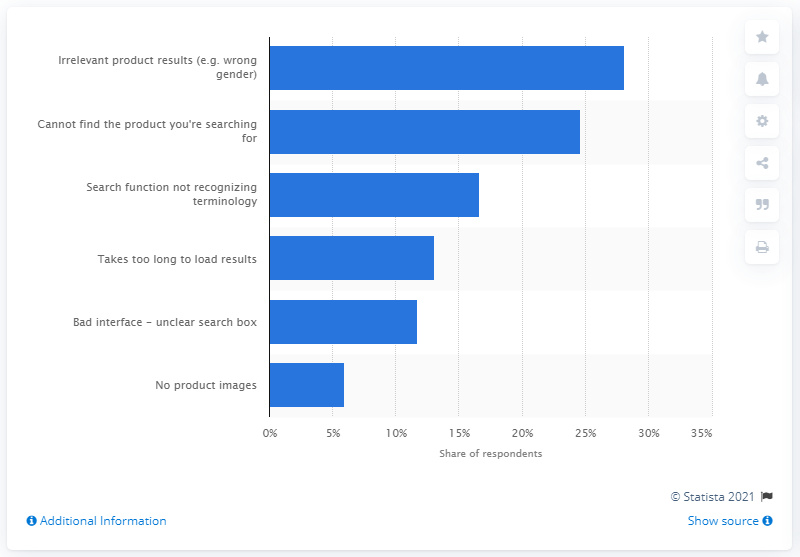Highlight a few significant elements in this photo. According to the survey, 13.1% of shoppers expressed frustration with the time it took to load search results. 